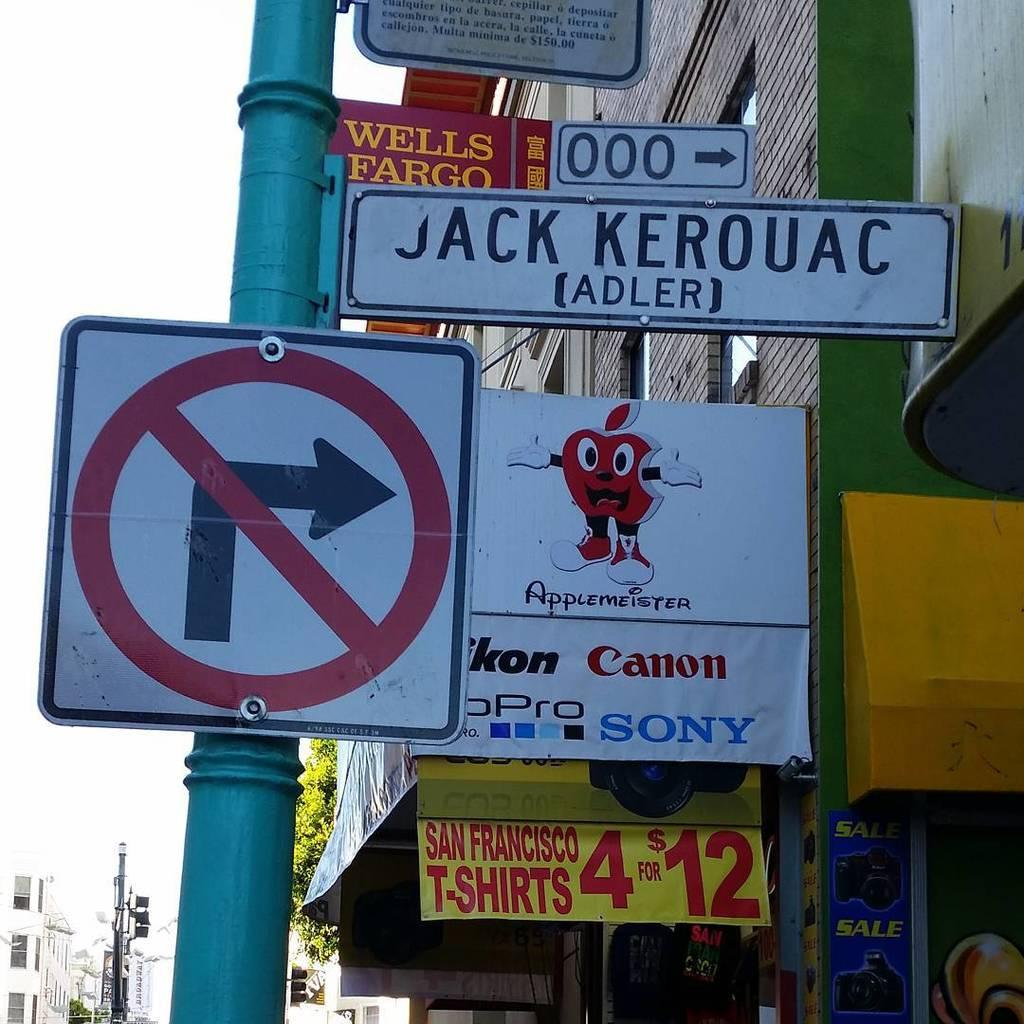<image>
Render a clear and concise summary of the photo. A no turn right street sign next to a store with a sign on it that says San Francisco T-shirts. 